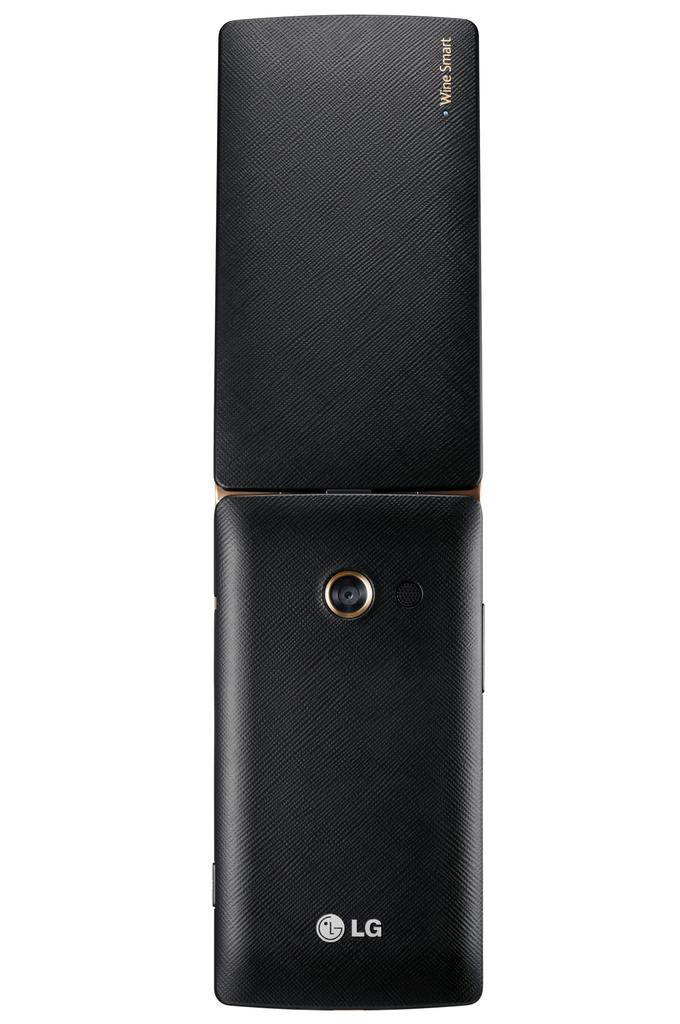What type of electronic device is visible in the image? There is an LG phone in the image. What type of brass rake is visible in the image? There is no brass rake present in the image; it only features an LG phone. 